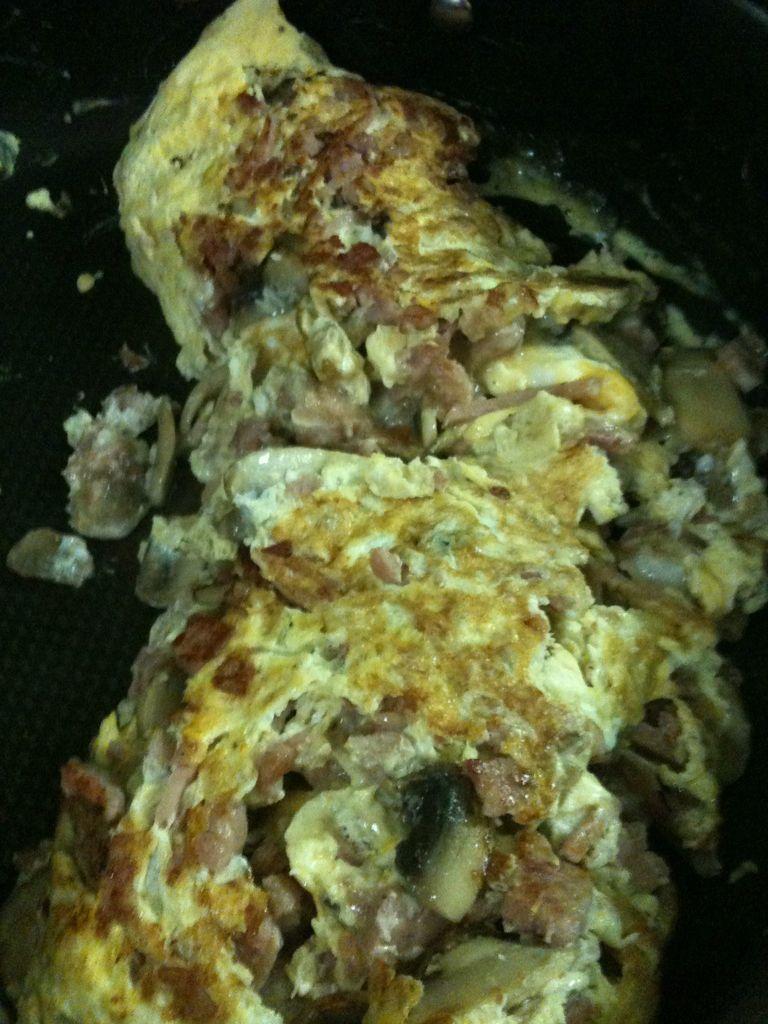In one or two sentences, can you explain what this image depicts? In this image, we can see some food item in a container. 